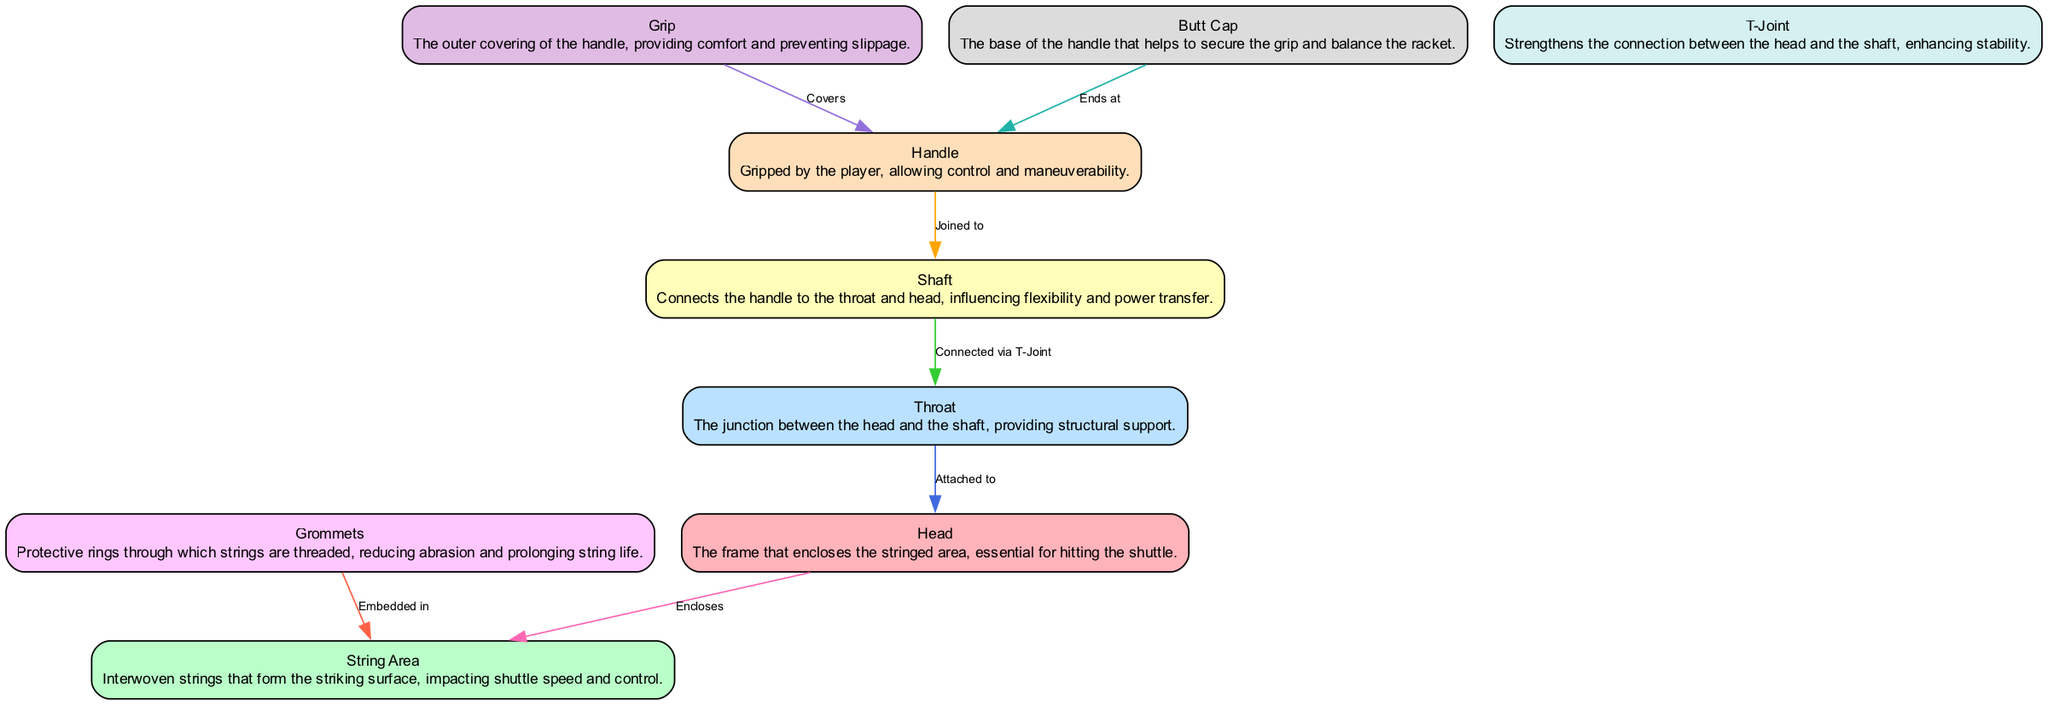What is the function of the grip? The grip is described as the outer covering of the handle, which provides comfort and prevents slippage.
Answer: Comfort and slippage prevention How many nodes are in the diagram? There are a total of 9 nodes listed in the provided data corresponding to the various parts of the badminton racket.
Answer: 9 What part connects the handle to the throat and head? The shaft is identified as the component that connects the handle to both the throat and the head of the racket.
Answer: Shaft What relationship exists between the head and the string area? The relationship stated in the data is that the head encloses the string area in the badminton racket's anatomy.
Answer: Encloses What connects the shaft to the throat? The T-joint is mentioned as the connector between the shaft and the throat, providing strength in that junction.
Answer: T-Joint How does the grommets contribute to the string area? Grommets are embedded in the string area, serving to protect the strings and prolong their life by reducing abrasion.
Answer: Embedded in What is the structural support part of the badminton racket? The throat provides the structural support as it is the junction between the head and the shaft.
Answer: Throat What covers the handle? The grip covers the handle and is essential for a player to maintain control.
Answer: Grip What is found at the base of the handle? The butt cap is at the base of the handle and helps in securing the grip and balancing the racket.
Answer: Butt Cap 